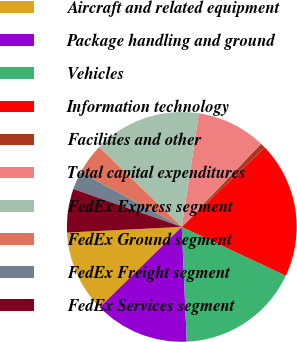Convert chart to OTSL. <chart><loc_0><loc_0><loc_500><loc_500><pie_chart><fcel>Aircraft and related equipment<fcel>Package handling and ground<fcel>Vehicles<fcel>Information technology<fcel>Facilities and other<fcel>Total capital expenditures<fcel>FedEx Express segment<fcel>FedEx Ground segment<fcel>FedEx Freight segment<fcel>FedEx Services segment<nl><fcel>11.55%<fcel>13.36%<fcel>17.33%<fcel>19.13%<fcel>0.72%<fcel>9.75%<fcel>15.16%<fcel>4.33%<fcel>2.53%<fcel>6.14%<nl></chart> 